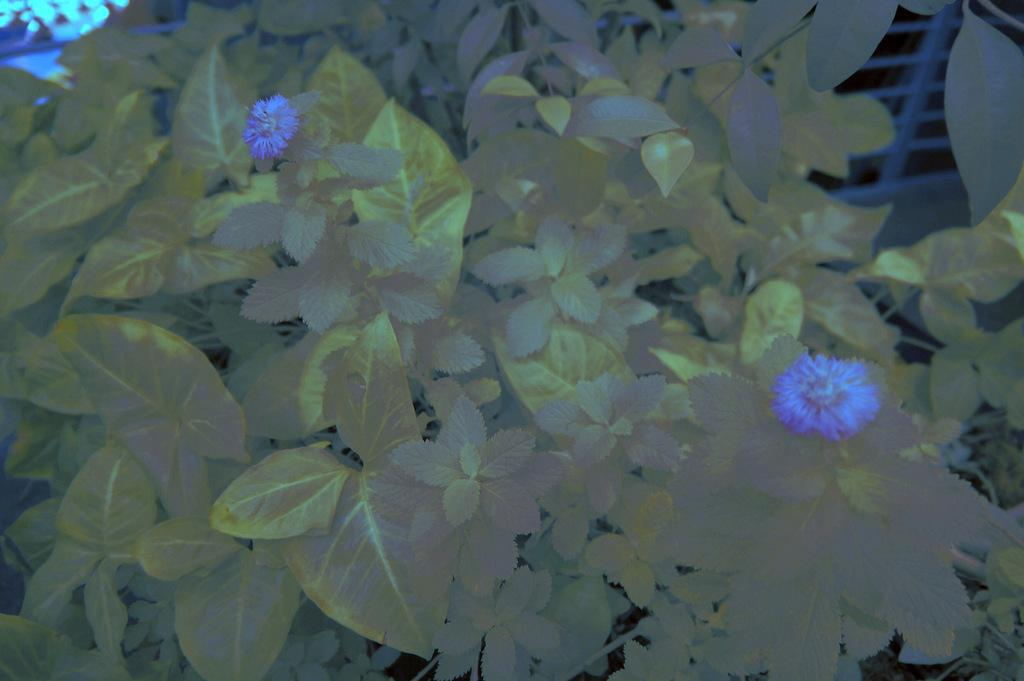What type of living organisms are present in the image? There are plants in the image. What specific features can be observed on the plants? The plants have leaves and flowers. What color are the flowers on the plants? The flowers are blue in color. How does the plant teach the concept of motion in the image? There is no indication in the image that the plant is teaching any concept, including motion. 